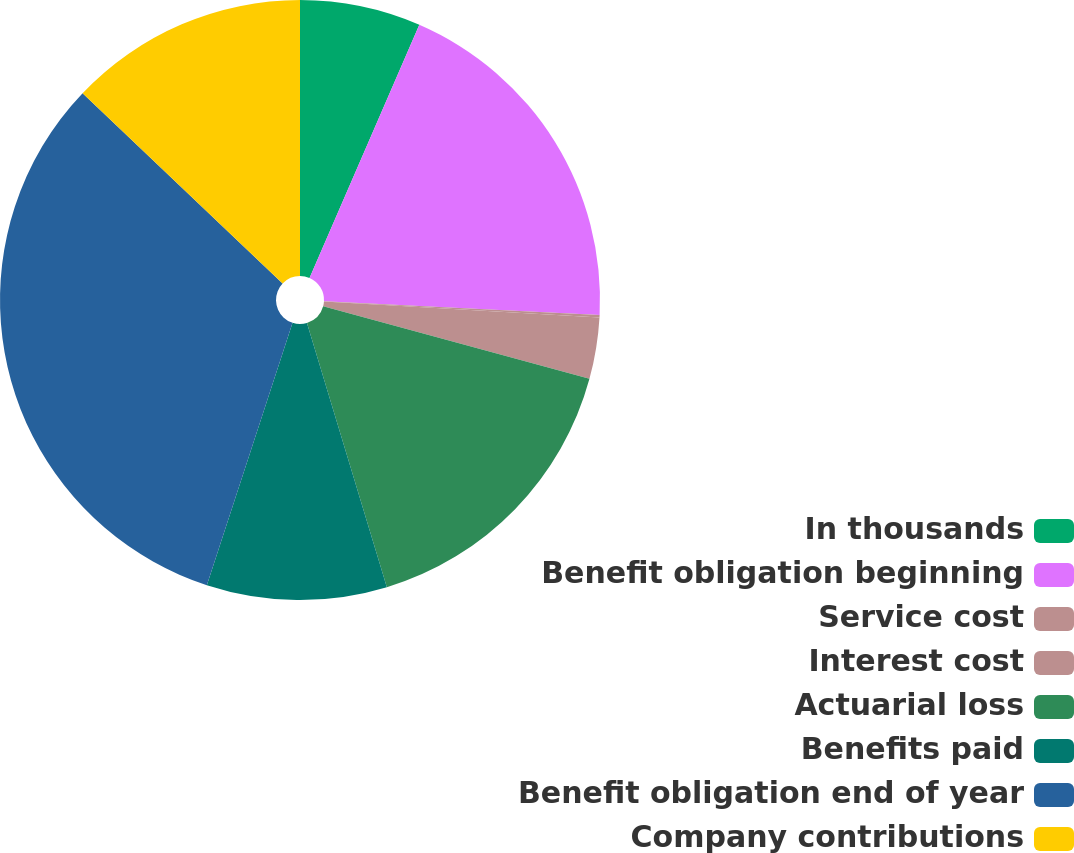<chart> <loc_0><loc_0><loc_500><loc_500><pie_chart><fcel>In thousands<fcel>Benefit obligation beginning<fcel>Service cost<fcel>Interest cost<fcel>Actuarial loss<fcel>Benefits paid<fcel>Benefit obligation end of year<fcel>Company contributions<nl><fcel>6.51%<fcel>19.29%<fcel>0.12%<fcel>3.31%<fcel>16.09%<fcel>9.7%<fcel>32.07%<fcel>12.9%<nl></chart> 